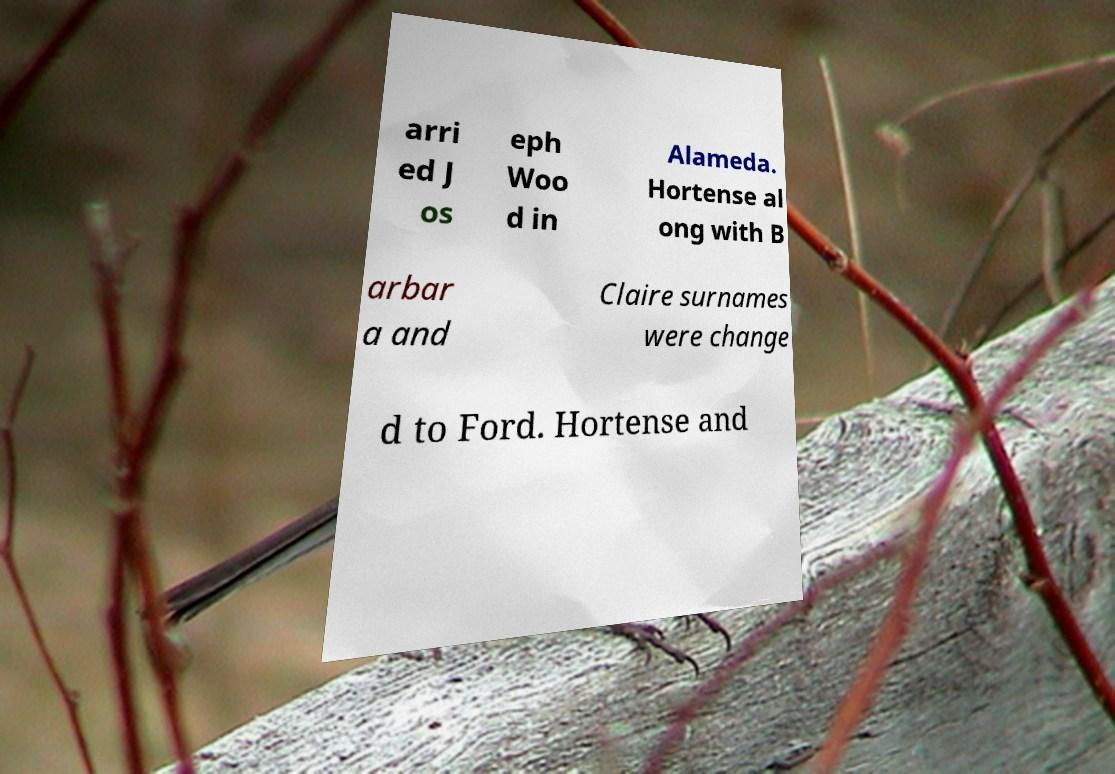Could you assist in decoding the text presented in this image and type it out clearly? arri ed J os eph Woo d in Alameda. Hortense al ong with B arbar a and Claire surnames were change d to Ford. Hortense and 